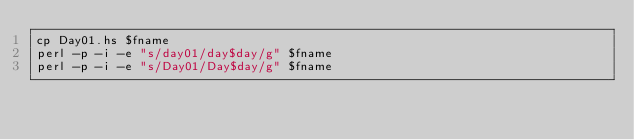Convert code to text. <code><loc_0><loc_0><loc_500><loc_500><_Bash_>cp Day01.hs $fname
perl -p -i -e "s/day01/day$day/g" $fname
perl -p -i -e "s/Day01/Day$day/g" $fname
</code> 